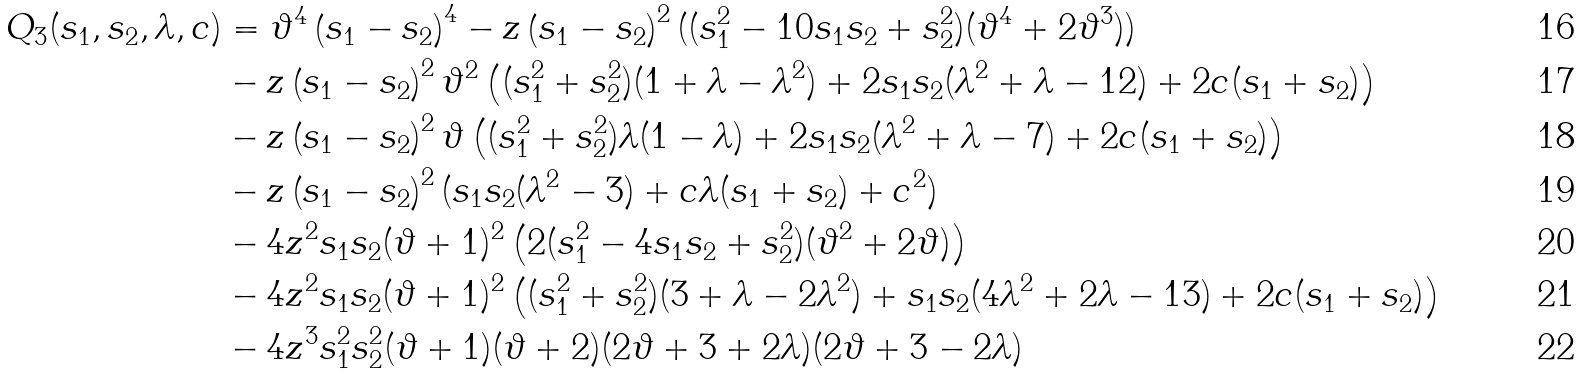<formula> <loc_0><loc_0><loc_500><loc_500>Q _ { 3 } ( s _ { 1 } , s _ { 2 } , \lambda , c ) & = { \vartheta } ^ { 4 } \left ( s _ { 1 } - s _ { 2 } \right ) ^ { 4 } - z \left ( s _ { 1 } - s _ { 2 } \right ) ^ { 2 } ( ( s ^ { 2 } _ { 1 } - 1 0 s _ { 1 } s _ { 2 } + s ^ { 2 } _ { 2 } ) ( \vartheta ^ { 4 } + 2 \vartheta ^ { 3 } ) ) \\ & - z \left ( s _ { 1 } - s _ { 2 } \right ) ^ { 2 } \vartheta ^ { 2 } \left ( ( s _ { 1 } ^ { 2 } + s _ { 2 } ^ { 2 } ) ( 1 + \lambda - \lambda ^ { 2 } ) + 2 s _ { 1 } s _ { 2 } ( \lambda ^ { 2 } + \lambda - 1 2 ) + 2 c ( s _ { 1 } + s _ { 2 } ) \right ) \\ & - z \left ( s _ { 1 } - s _ { 2 } \right ) ^ { 2 } \vartheta \left ( ( s _ { 1 } ^ { 2 } + s _ { 2 } ^ { 2 } ) \lambda ( 1 - \lambda ) + 2 s _ { 1 } s _ { 2 } ( \lambda ^ { 2 } + \lambda - 7 ) + 2 c ( s _ { 1 } + s _ { 2 } ) \right ) \\ & - z \left ( s _ { 1 } - s _ { 2 } \right ) ^ { 2 } ( s _ { 1 } s _ { 2 } ( \lambda ^ { 2 } - 3 ) + c \lambda ( s _ { 1 } + s _ { 2 } ) + c ^ { 2 } ) \\ & - 4 z ^ { 2 } s _ { 1 } s _ { 2 } ( \vartheta + 1 ) ^ { 2 } \left ( 2 ( s ^ { 2 } _ { 1 } - 4 s _ { 1 } s _ { 2 } + s ^ { 2 } _ { 2 } ) ( \vartheta ^ { 2 } + 2 \vartheta ) \right ) \\ & - 4 z ^ { 2 } s _ { 1 } s _ { 2 } ( \vartheta + 1 ) ^ { 2 } \left ( ( s _ { 1 } ^ { 2 } + s _ { 2 } ^ { 2 } ) ( 3 + \lambda - 2 \lambda ^ { 2 } ) + s _ { 1 } s _ { 2 } ( 4 \lambda ^ { 2 } + 2 \lambda - 1 3 ) + 2 c ( s _ { 1 } + s _ { 2 } ) \right ) \\ & - 4 z ^ { 3 } s _ { 1 } ^ { 2 } s _ { 2 } ^ { 2 } ( \vartheta + 1 ) ( \vartheta + 2 ) ( 2 \vartheta + 3 + 2 \lambda ) ( 2 \vartheta + 3 - 2 \lambda )</formula> 